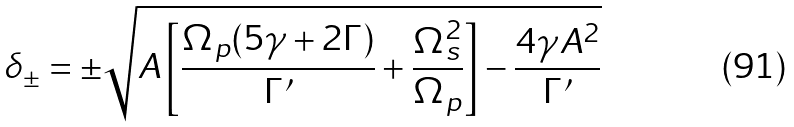<formula> <loc_0><loc_0><loc_500><loc_500>\delta _ { \pm } = \pm \sqrt { A \left [ \frac { \Omega _ { p } ( 5 \gamma + 2 \Gamma ) } { \Gamma ^ { \prime } } + \frac { \Omega _ { s } ^ { 2 } } { \Omega _ { p } } \right ] - \frac { 4 \gamma A ^ { 2 } } { \Gamma ^ { \prime } } }</formula> 